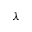<formula> <loc_0><loc_0><loc_500><loc_500>\lambda</formula> 